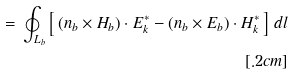<formula> <loc_0><loc_0><loc_500><loc_500>= \, \oint _ { L _ { b } } \left [ \, ( { n } _ { b } \times { H } _ { b } ) \cdot { E } _ { k } ^ { * } - ( { n } _ { b } \times { E } _ { b } ) \cdot { H } _ { k } ^ { * } \, \right ] \, d l \\ [ . 2 c m ]</formula> 